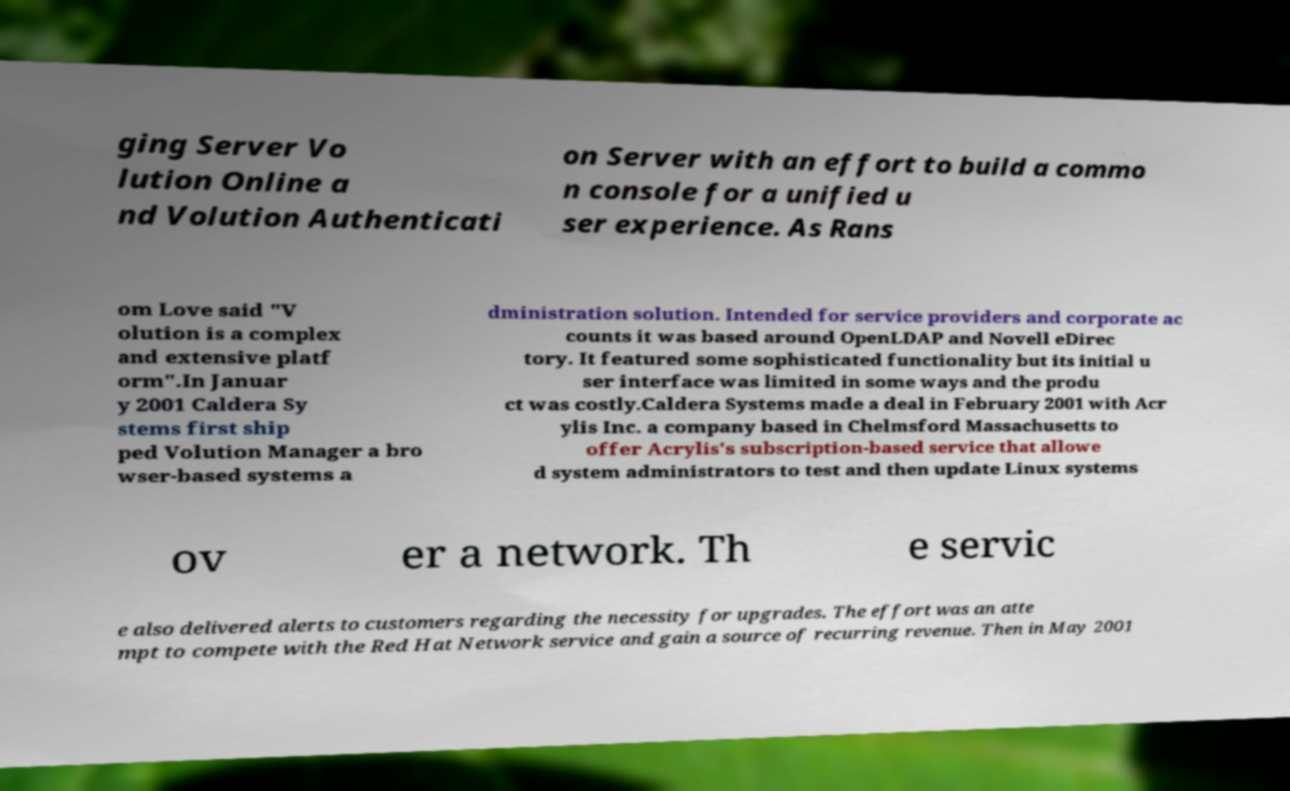Please read and relay the text visible in this image. What does it say? ging Server Vo lution Online a nd Volution Authenticati on Server with an effort to build a commo n console for a unified u ser experience. As Rans om Love said "V olution is a complex and extensive platf orm".In Januar y 2001 Caldera Sy stems first ship ped Volution Manager a bro wser-based systems a dministration solution. Intended for service providers and corporate ac counts it was based around OpenLDAP and Novell eDirec tory. It featured some sophisticated functionality but its initial u ser interface was limited in some ways and the produ ct was costly.Caldera Systems made a deal in February 2001 with Acr ylis Inc. a company based in Chelmsford Massachusetts to offer Acrylis's subscription-based service that allowe d system administrators to test and then update Linux systems ov er a network. Th e servic e also delivered alerts to customers regarding the necessity for upgrades. The effort was an atte mpt to compete with the Red Hat Network service and gain a source of recurring revenue. Then in May 2001 